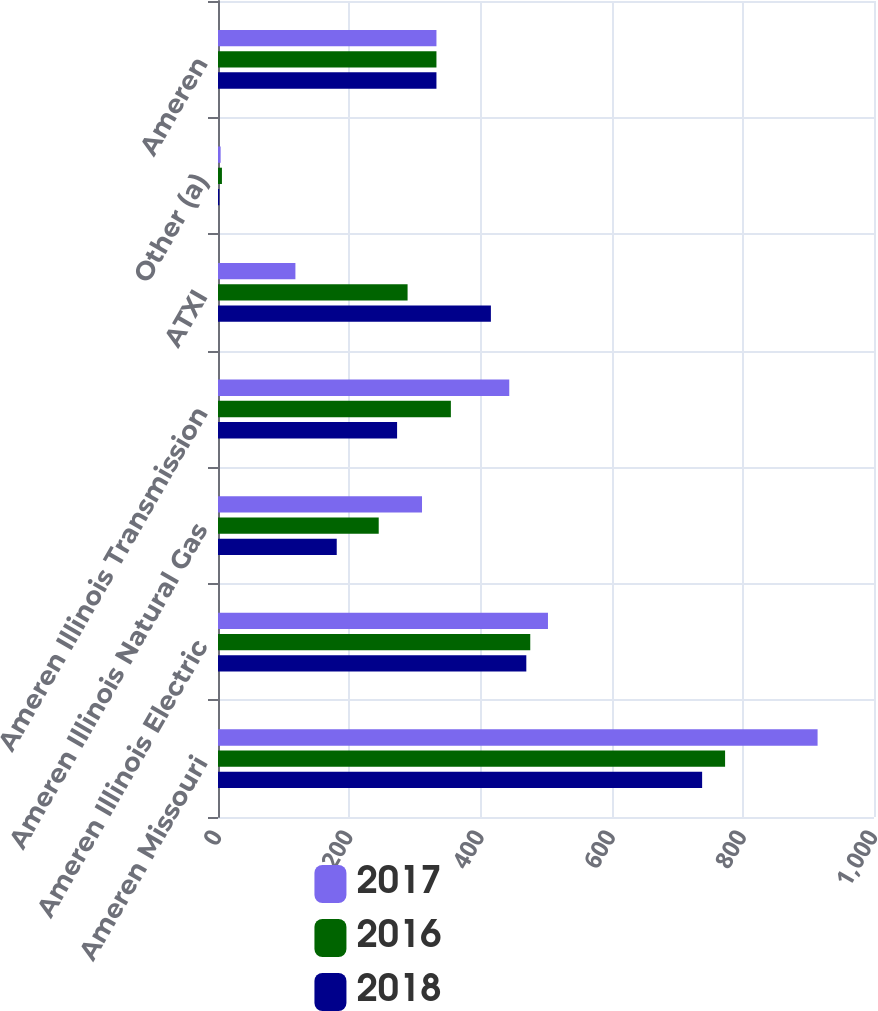Convert chart to OTSL. <chart><loc_0><loc_0><loc_500><loc_500><stacked_bar_chart><ecel><fcel>Ameren Missouri<fcel>Ameren Illinois Electric<fcel>Ameren Illinois Natural Gas<fcel>Ameren Illinois Transmission<fcel>ATXI<fcel>Other (a)<fcel>Ameren<nl><fcel>2017<fcel>914<fcel>503<fcel>311<fcel>444<fcel>118<fcel>4<fcel>333<nl><fcel>2016<fcel>773<fcel>476<fcel>245<fcel>355<fcel>289<fcel>6<fcel>333<nl><fcel>2018<fcel>738<fcel>470<fcel>181<fcel>273<fcel>416<fcel>2<fcel>333<nl></chart> 